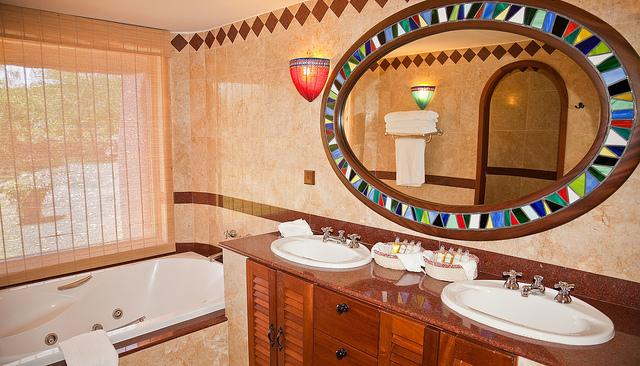Why does the tub have round silver objects on it? water jets 